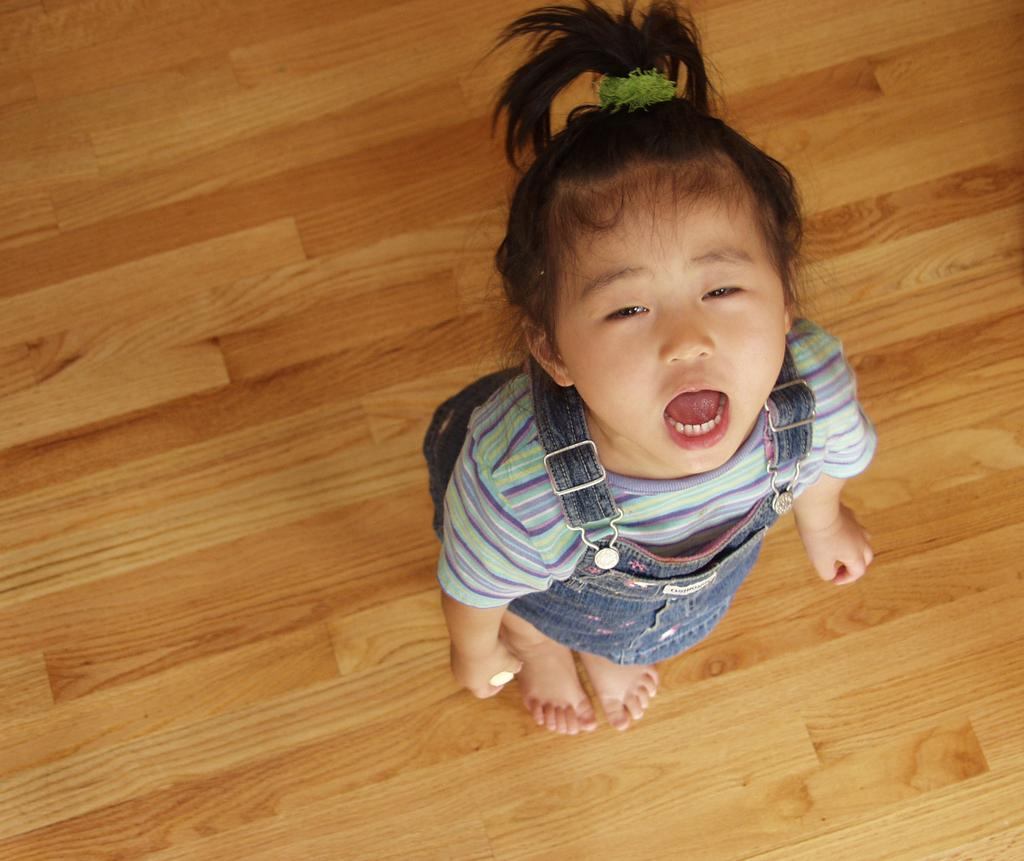Who is the main subject in the image? There is a small girl in the image. What type of surface is the girl standing on? The girl is standing on wooden flooring. What is the girl doing in the image? The girl is shouting. What type of bear can be seen standing next to the girl in the image? There is no bear present in the image; it only features a small girl. How many ants are crawling on the girl's shoes in the image? There is no mention of ants in the image, so it is impossible to determine their presence or quantity. 